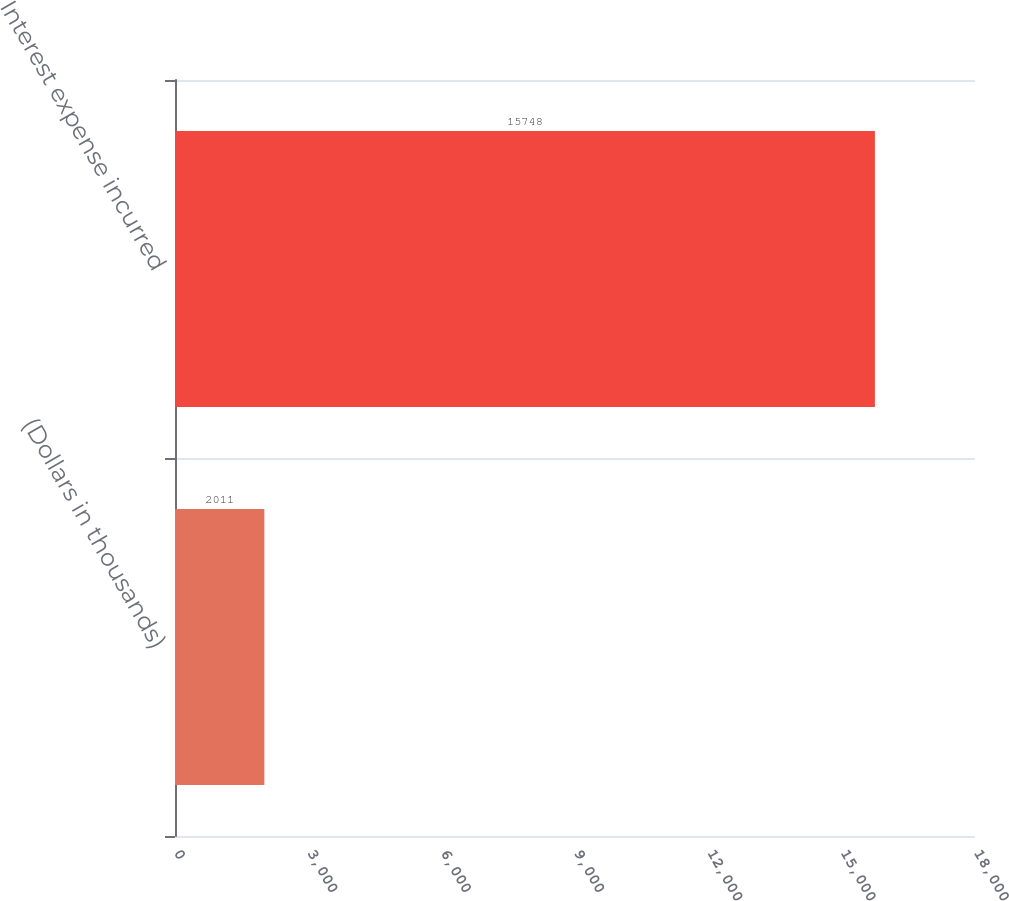Convert chart to OTSL. <chart><loc_0><loc_0><loc_500><loc_500><bar_chart><fcel>(Dollars in thousands)<fcel>Interest expense incurred<nl><fcel>2011<fcel>15748<nl></chart> 